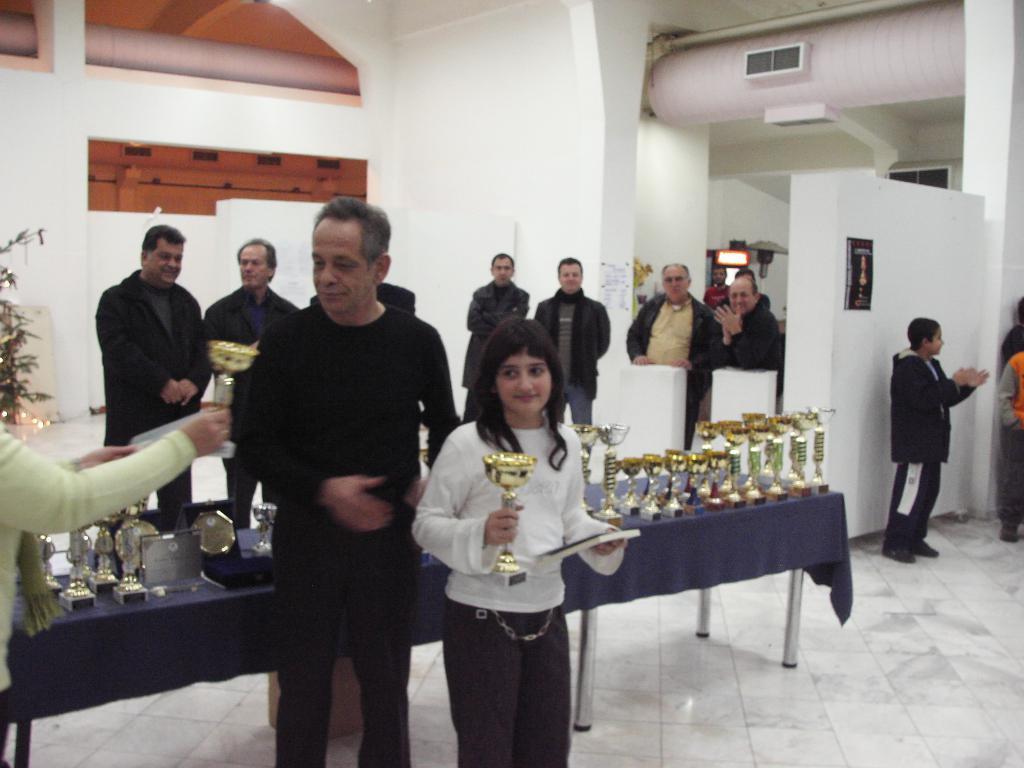How would you summarize this image in a sentence or two? This is an inside view. Here I can see a girl holding a trophy and a books in the hands and standing. On the left side a person is giving a trophy to a man. At the back of these people there is a table which is covered with a cloth on which I can see many trophies. In the background few people are standing and also I can see the wall. 